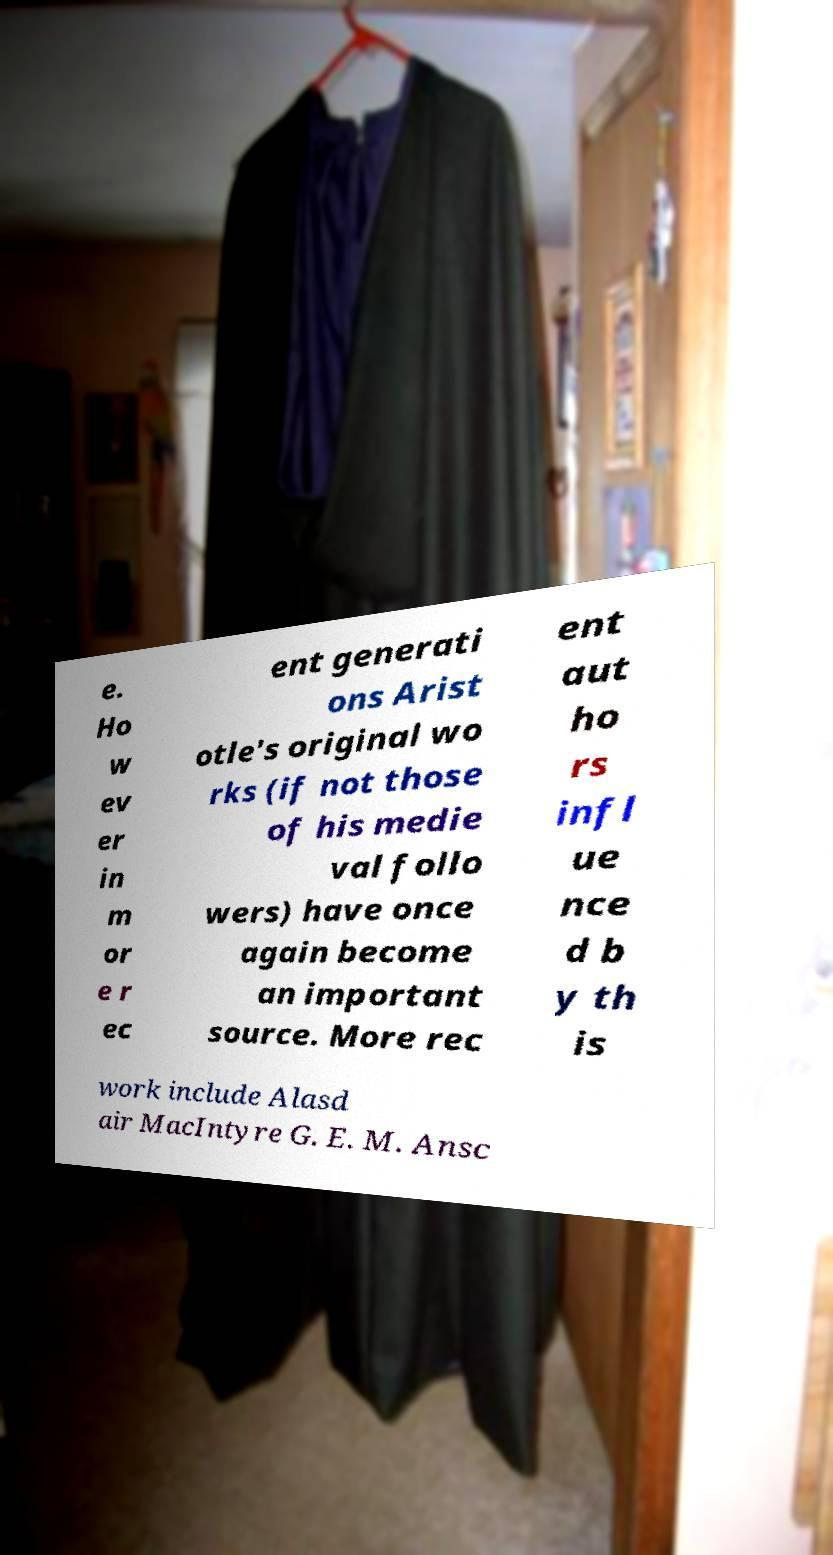What messages or text are displayed in this image? I need them in a readable, typed format. e. Ho w ev er in m or e r ec ent generati ons Arist otle's original wo rks (if not those of his medie val follo wers) have once again become an important source. More rec ent aut ho rs infl ue nce d b y th is work include Alasd air MacIntyre G. E. M. Ansc 